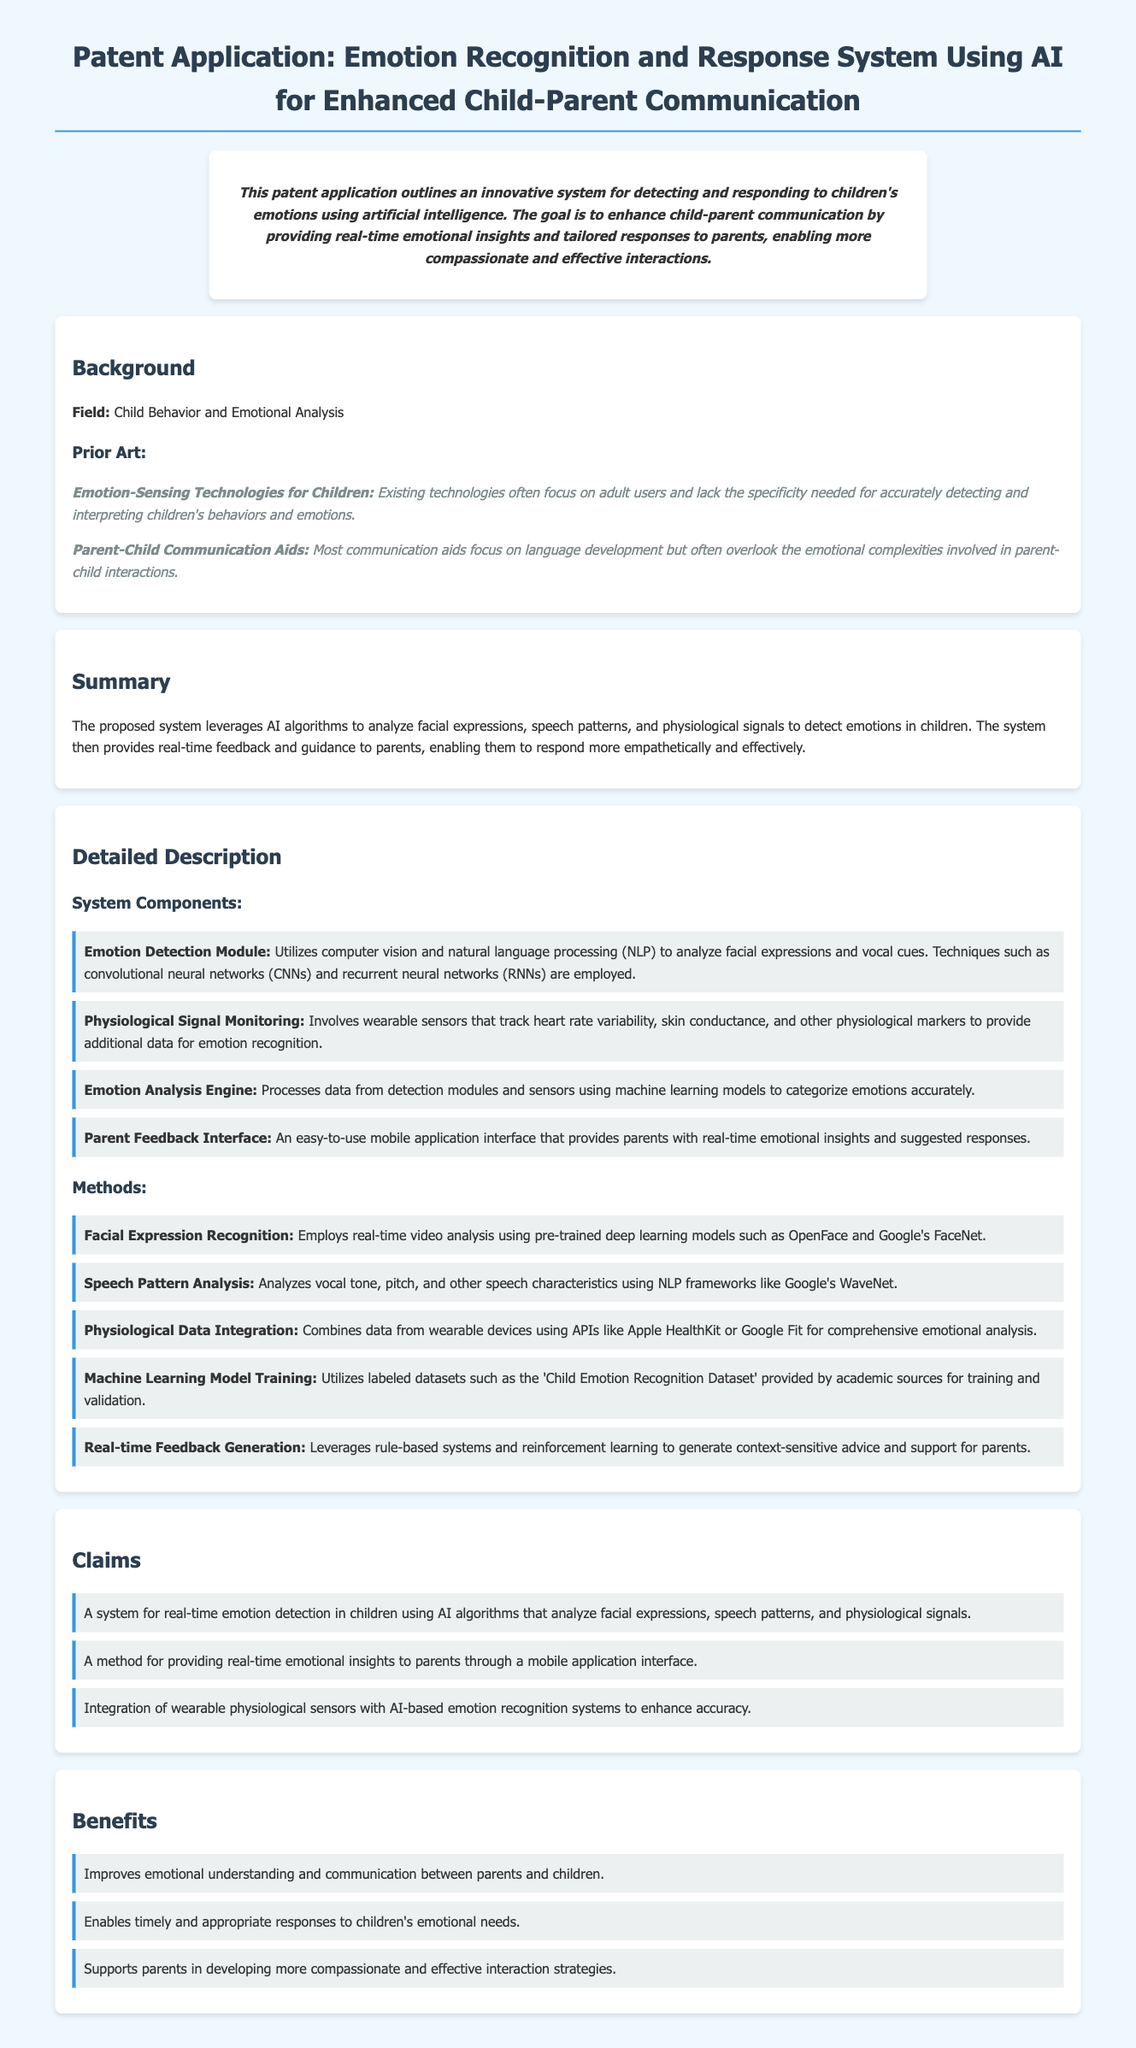what is the main purpose of the system? The system aims to enhance child-parent communication by providing real-time emotional insights and tailored responses to parents.
Answer: enhance child-parent communication what technology is primarily used for facial expression recognition? The document mentions the use of pre-trained deep learning models such as OpenFace and Google's FaceNet for facial expression recognition.
Answer: OpenFace and Google's FaceNet what type of data does the physiological signal monitoring collect? Physiological signal monitoring involves tracking heart rate variability, skin conductance, and other physiological markers.
Answer: heart rate variability, skin conductance how does the system provide feedback to parents? The feedback is provided through an easy-to-use mobile application interface that offers real-time emotional insights.
Answer: mobile application interface what is the first claim of the patent? The first claim discusses a system for real-time emotion detection in children using AI algorithms that analyze various signals.
Answer: A system for real-time emotion detection in children using AI algorithms what are the benefits of using this system? The benefits include improved emotional understanding and communication, timely responses to emotional needs, and support for compassionate interaction strategies.
Answer: improved emotional understanding and communication which field does this patent primarily focus on? The patent primarily focuses on the field of Child Behavior and Emotional Analysis.
Answer: Child Behavior and Emotional Analysis which machine learning techniques are mentioned in the document? The document mentions convolutional neural networks (CNNs) and recurrent neural networks (RNNs) as the techniques used in the emotion detection module.
Answer: convolutional neural networks (CNNs) and recurrent neural networks (RNNs) 